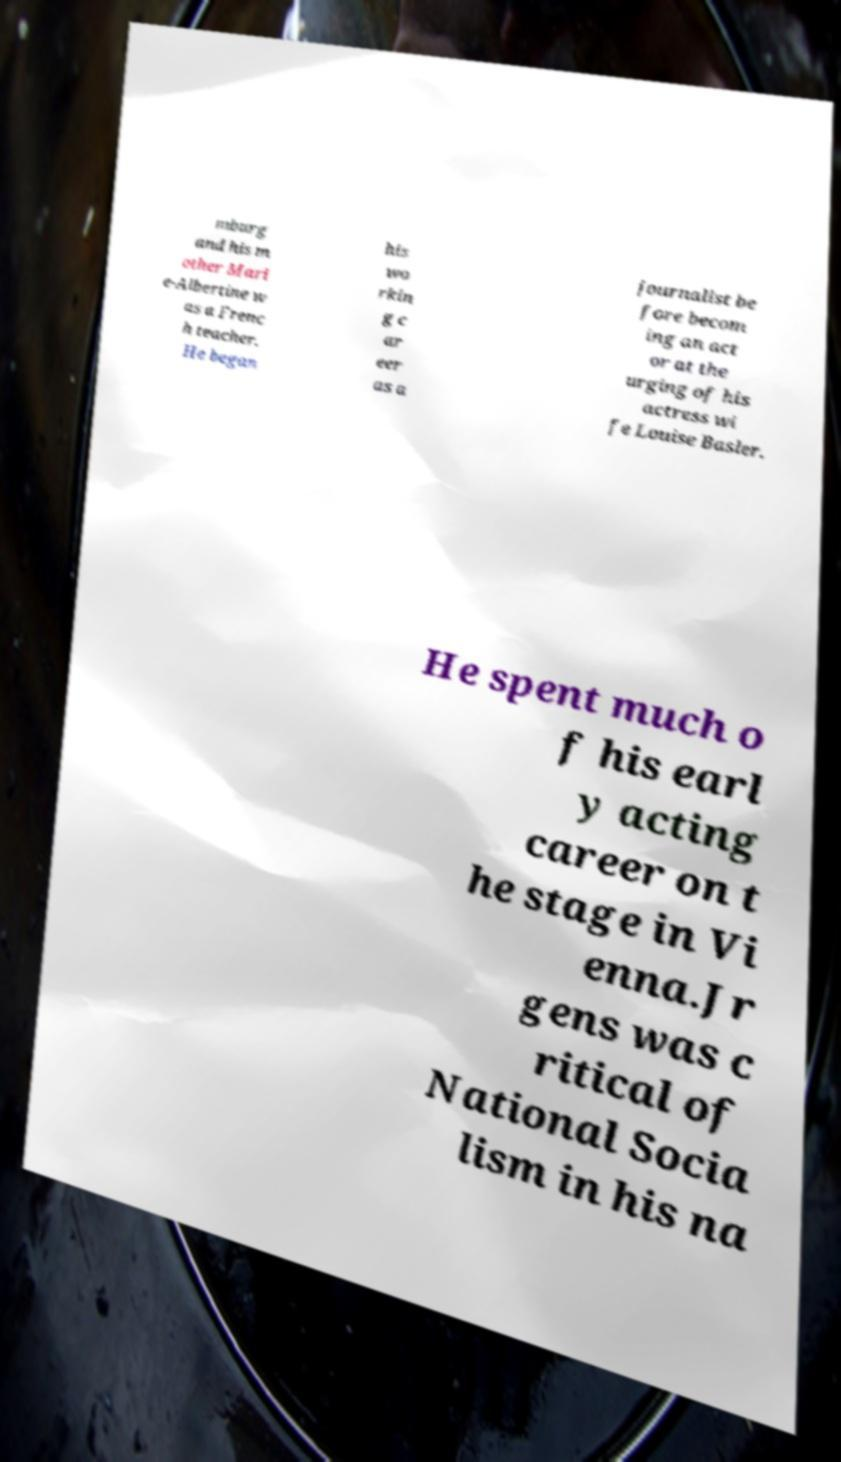There's text embedded in this image that I need extracted. Can you transcribe it verbatim? mburg and his m other Mari e-Albertine w as a Frenc h teacher. He began his wo rkin g c ar eer as a journalist be fore becom ing an act or at the urging of his actress wi fe Louise Basler. He spent much o f his earl y acting career on t he stage in Vi enna.Jr gens was c ritical of National Socia lism in his na 